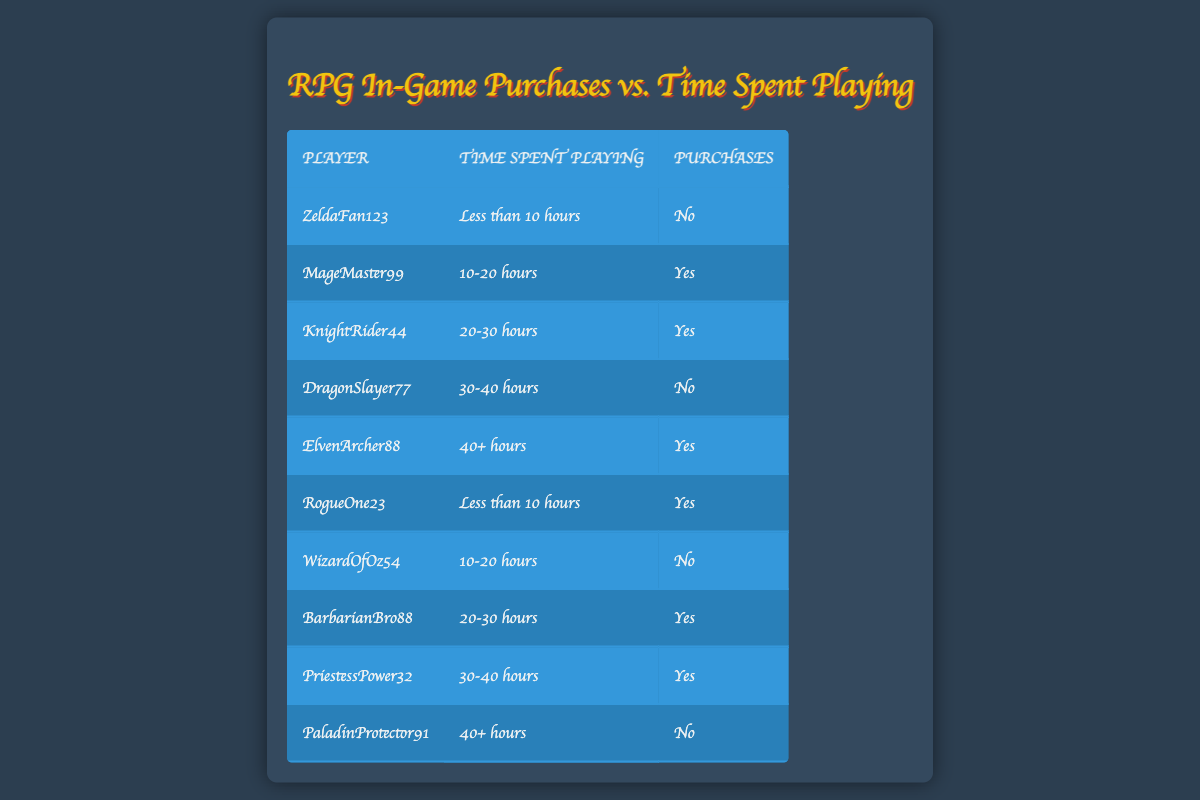What is the total number of players who made in-game purchases? To find the total number of players who made purchases, I count the occurrences of "Yes" in the Purchases column. The players who made purchases are MageMaster99, KnightRider44, RogueOne23, BarbarianBro88, ElvenArcher88, and PriestessPower32, which totals to 6 players.
Answer: 6 How many players spent less than 10 hours and made purchases? I look at the Time Spent Playing column for "Less than 10 hours" and check the Purchases column to see if the value is "Yes." The players are RogueOne23, so there is 1 player.
Answer: 1 Is it true that all players who played for 40+ hours made purchases? I check the players in the 40+ hours row, which are ElvenArcher88 and PaladinProtector91. ElvenArcher88 made a purchase, but PaladinProtector91 did not. Since not all players in this group made purchases, the statement is false.
Answer: No What percentage of players who spent 30-40 hours made purchases? I first determine how many players fall under the 30-40 hours group. There are 2 players: DragonSlayer77 (No) and PriestessPower32 (Yes). To calculate the percentage, I have 1 out of 2 players who made purchases, so the percentage is (1/2) * 100 = 50%.
Answer: 50% How many players spent between 10-20 hours without making purchases? I look at the rows with "10-20 hours" and check the Purchases column. The players are MageMaster99 (Yes) and WizardOfOz54 (No), so only WizardOfOz54 fits, totaling 1 player.
Answer: 1 Which time category has the highest number of players who made purchases? I count the number of "Yes" purchases across each time category. For "Less than 10 hours," there is 1 player; "10-20 hours" has 1 player; "20-30 hours" has 2 players; "30-40 hours" has 1 player; and "40+ hours" has 1 player, giving "20-30 hours" the highest purchases with 2 players.
Answer: 20-30 hours What is the total number of players who did not make in-game purchases? I count the occurrences of "No" in the Purchases column. The players are ZeldaFan123, DragonSlayer77, WizardOfOz54, and PaladinProtector91, which totals to 4 players.
Answer: 4 Are there any players who played for less than 10 hours and also made purchases? I look for players in the "Less than 10 hours" group in the table. The players are ZeldaFan123 (No) and RogueOne23 (Yes). Since there is at least one player (RogueOne23) who made a purchase, the answer is yes.
Answer: Yes 